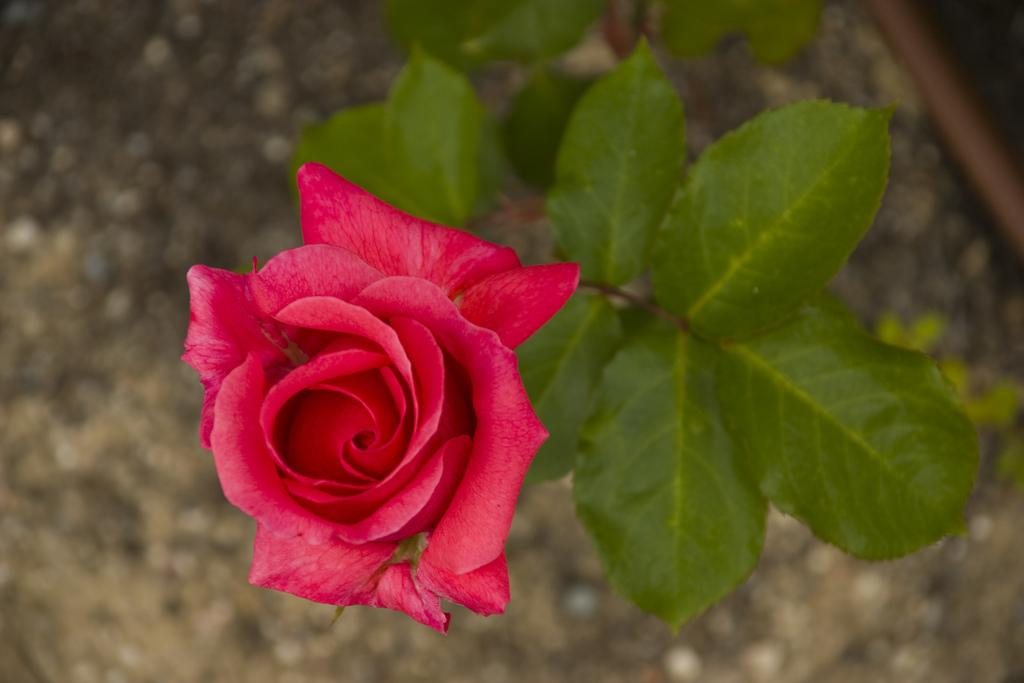What type of flower can be seen in the image? There is a red colored flower in the image. What else is present in the image besides the flower? There is a plant in the image. Can you describe the background of the image? The background of the image is blurred. How many trees are visible in the image? There are no trees visible in the image; it only features a red colored flower and a plant. What type of furniture can be seen in the image? There is no furniture present in the image. 